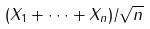<formula> <loc_0><loc_0><loc_500><loc_500>( X _ { 1 } + \cdot \cdot \cdot + X _ { n } ) / \sqrt { n }</formula> 